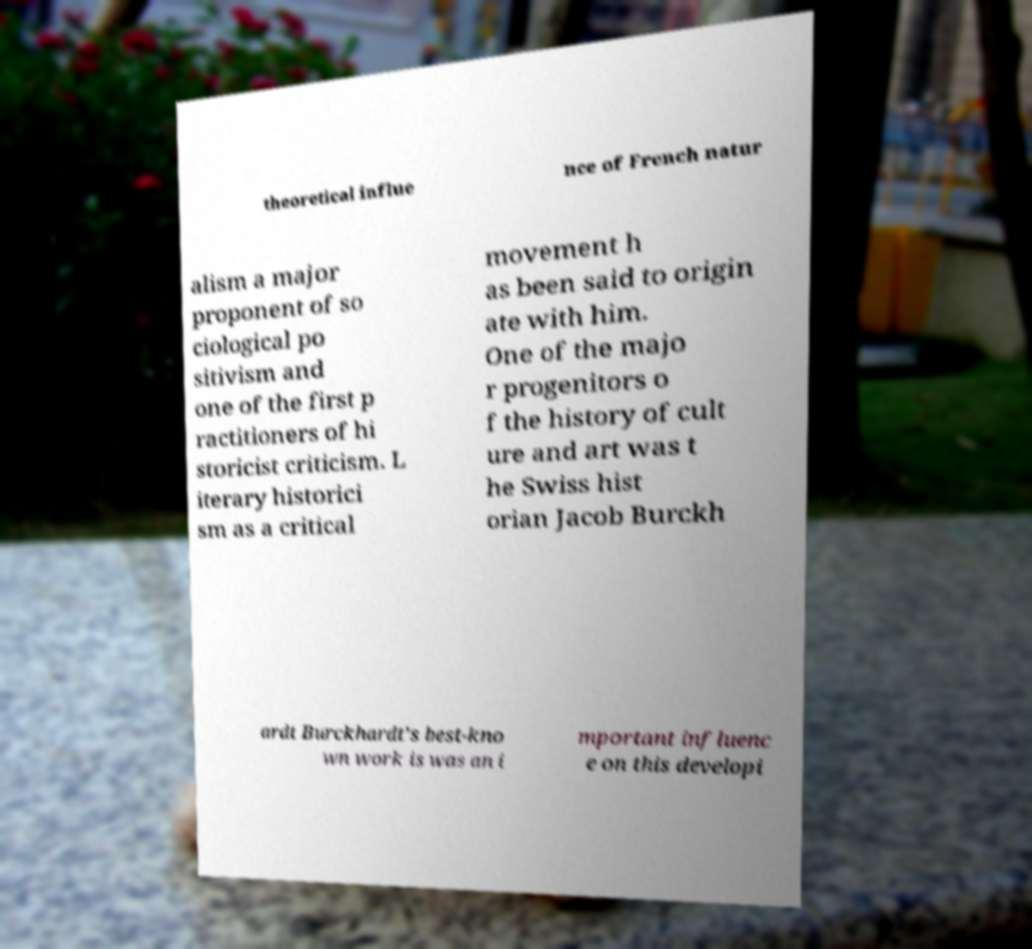For documentation purposes, I need the text within this image transcribed. Could you provide that? theoretical influe nce of French natur alism a major proponent of so ciological po sitivism and one of the first p ractitioners of hi storicist criticism. L iterary historici sm as a critical movement h as been said to origin ate with him. One of the majo r progenitors o f the history of cult ure and art was t he Swiss hist orian Jacob Burckh ardt Burckhardt's best-kno wn work is was an i mportant influenc e on this developi 